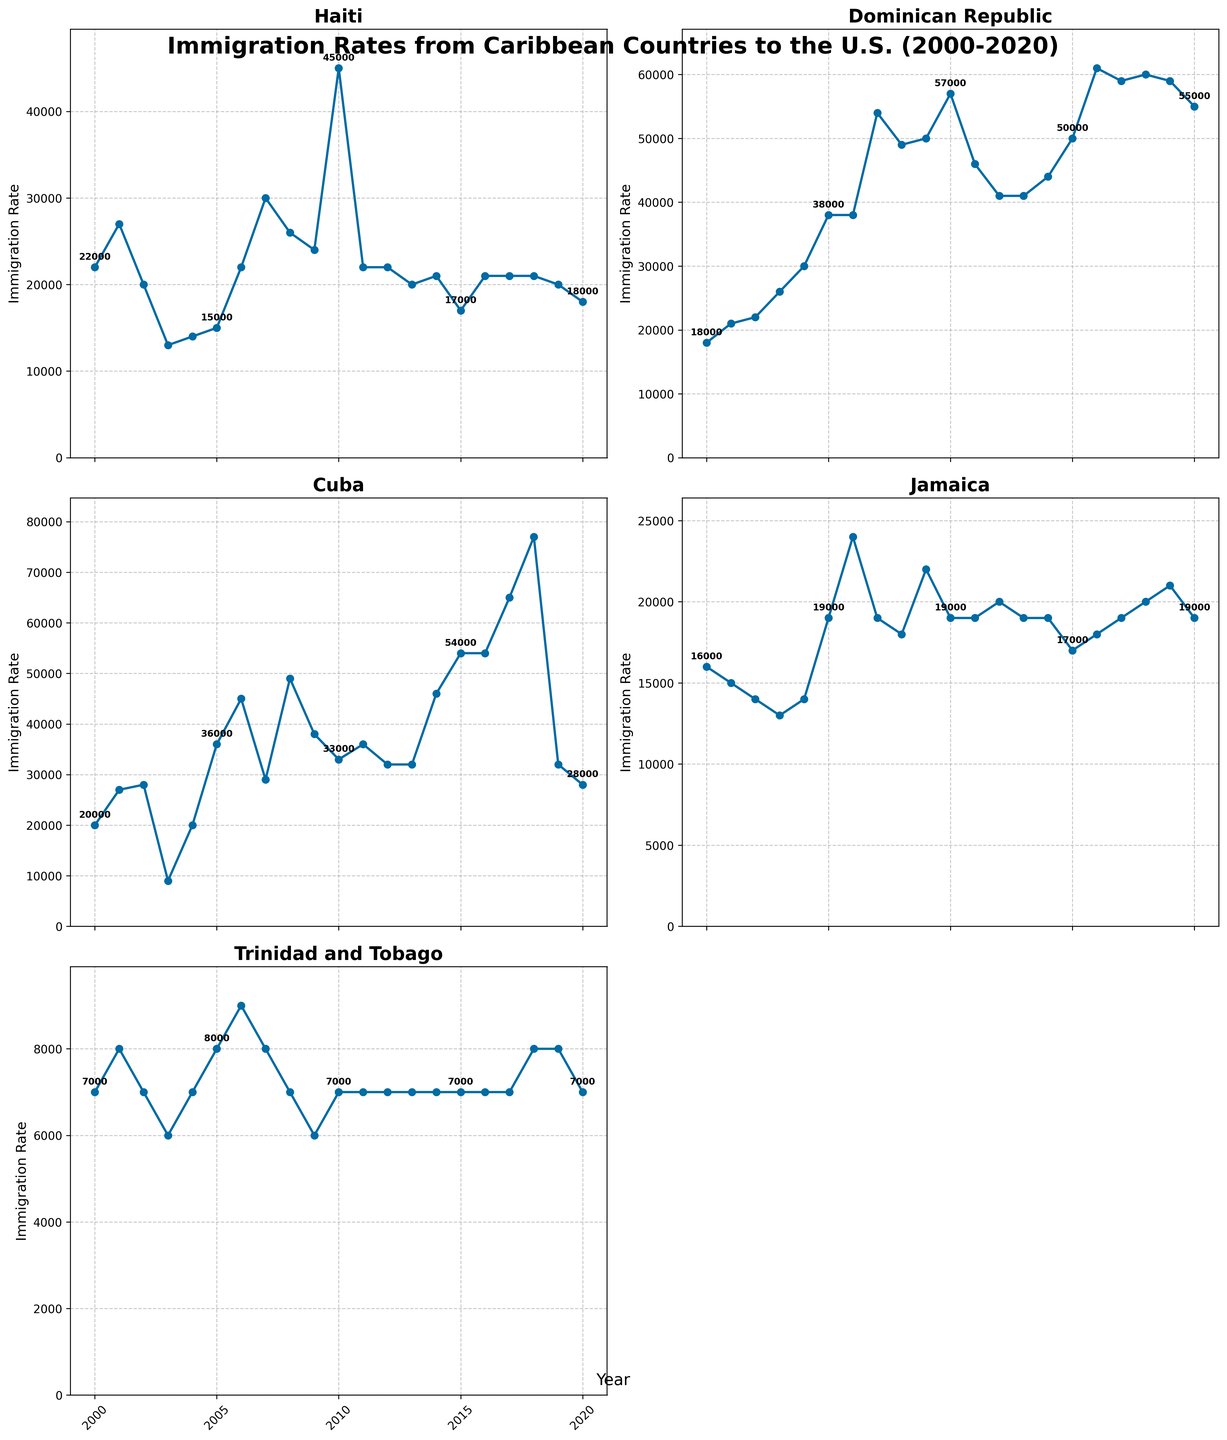What year did the Dominican Republic have the highest immigration rate? The plot for the Dominican Republic shows the highest point on the chart is labeled at 61000 in the year 2016.
Answer: 2016 Compare the immigration rates of Haiti and Cuba in 2010. Which country had a higher rate and by how much? In 2010, Haiti had an immigration rate of 45000, and Cuba had 33000. Subtracting these values, Haiti had 45000 - 33000 = 12000 more.
Answer: Haiti by 12000 What is the trend for Jamaica's immigration rate from 2000 to 2020? The plot for Jamaica shows peaks around 2006 and 2009 and a more consistent rate in the later years. Overall, it doesn't show a steep upward or downward trend but rather fluctuations around a middle range.
Answer: Fluctuating with no clear trend Calculate the average immigration rate for Trinidad and Tobago from 2000 to 2020. Summing the immigration rates for Trinidad and Tobago given (7000, 8000, 7000, 6000, 7000, 8000, 9000, 8000, 7000, 6000, 7000, 7000, 7000, 7000, 7000, 7000, 7000, 8000, 8000, 7000) yields 149000. Dividing by the number of years (21) gives an average rate: 149000/21 = 7095.24.
Answer: 7095 Which country had the largest decrease in immigration rate from its peak year to 2020? From the plots: Cuba peaked at 77000 in 2018 and dropped to 28000 in 2020, a decrease of 49000. The other countries' decreases are smaller, making this the largest.
Answer: Cuba During which 5-year span did the Dominican Republic experience the most significant rise in immigration rate? The plot shows the Dominican Republic's rate jumping significantly from 30000 in 2004 to 38000 in 2005, a rise of 8000. Reviewing 5-year spans, the biggest overall rise is between 2004 and 2009, going from 30000 to 50000, a jump of 20000.
Answer: 2004-2009 Identify the years where multiple countries had the same immigration rate. By examining the data points in the plots, it is noticeable that in 2000, both Haiti and Cuba had an immigration rate of 20000 each.
Answer: 2000 Compare the changes in immigration rates for Haiti and the Dominican Republic between 2000 and 2018. Who had the larger increase? For Haiti, the rate increased from 22000 to 21000, a 1000 decrease. For the Dominican Republic, the rate increased from 18000 to 60000, an increase of 42000.
Answer: Dominican Republic by 42000 